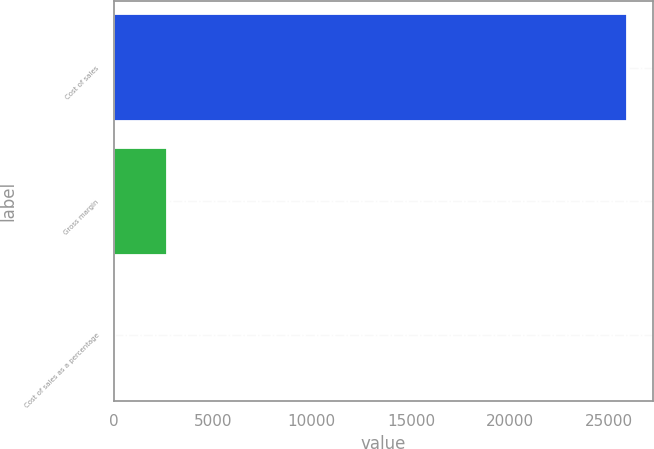<chart> <loc_0><loc_0><loc_500><loc_500><bar_chart><fcel>Cost of sales<fcel>Gross margin<fcel>Cost of sales as a percentage<nl><fcel>25916<fcel>2673.68<fcel>91.2<nl></chart> 